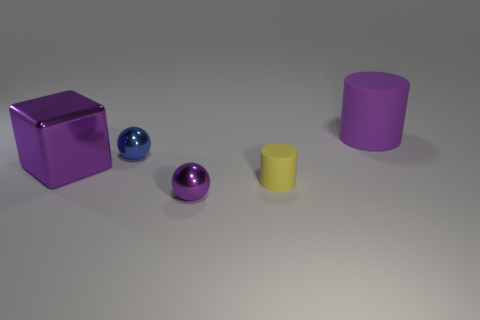Are there fewer purple rubber cylinders behind the small purple thing than tiny blue metal spheres that are on the right side of the big cube?
Provide a short and direct response. No. Is there a purple rubber thing in front of the rubber cylinder that is in front of the cylinder to the right of the yellow rubber thing?
Your response must be concise. No. There is a ball that is the same color as the cube; what is its material?
Your answer should be compact. Metal. Is the shape of the big rubber thing that is behind the yellow matte object the same as the tiny thing behind the cube?
Provide a succinct answer. No. There is a blue thing that is the same size as the yellow object; what is it made of?
Offer a terse response. Metal. Does the large purple thing that is behind the tiny blue shiny object have the same material as the tiny object that is behind the tiny rubber cylinder?
Offer a very short reply. No. What shape is the yellow object that is the same size as the blue metal object?
Ensure brevity in your answer.  Cylinder. How many other objects are there of the same color as the large matte thing?
Offer a terse response. 2. The tiny sphere that is behind the small purple sphere is what color?
Offer a very short reply. Blue. How many other things are made of the same material as the large purple cylinder?
Your answer should be compact. 1. 